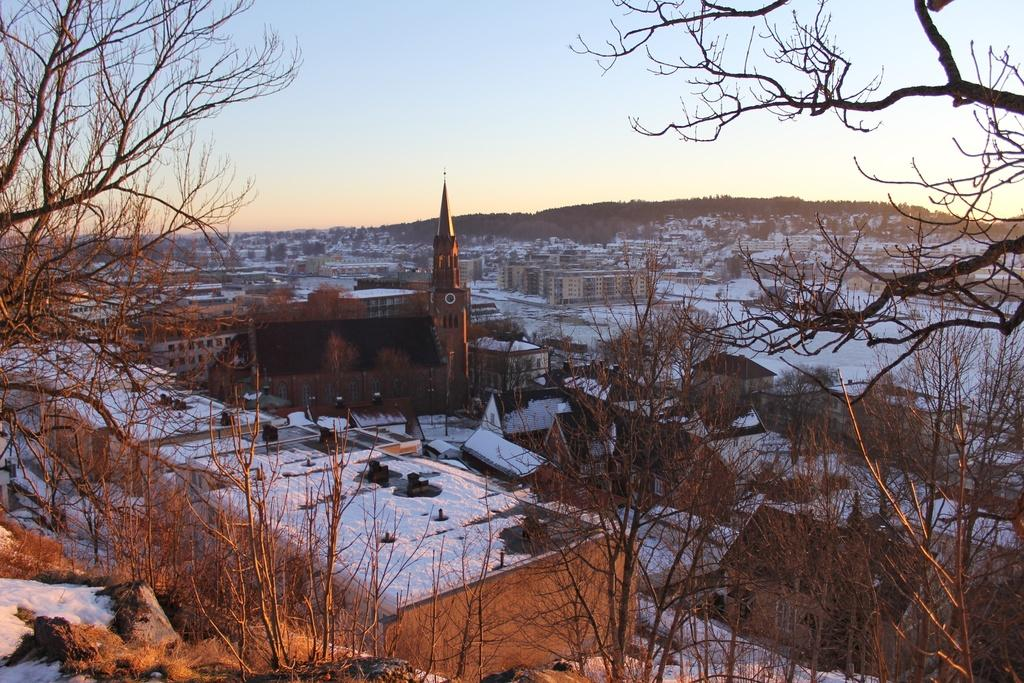What type of structures can be seen in the image? There are buildings in the image. What is the condition of the trees in the image? The trees in the image are dried. What type of vegetation is present in the image? There are plants in the image. What is the weather like in the image? There is snow visible in the image, indicating a cold or wintery environment. What can be seen in the background of the image? There are trees and the sky visible in the background of the image. What type of list is being compiled by the laborer in the image? There is no laborer or list present in the image. How much dirt is visible in the image? There is no dirt visible in the image; it features snow and buildings. 